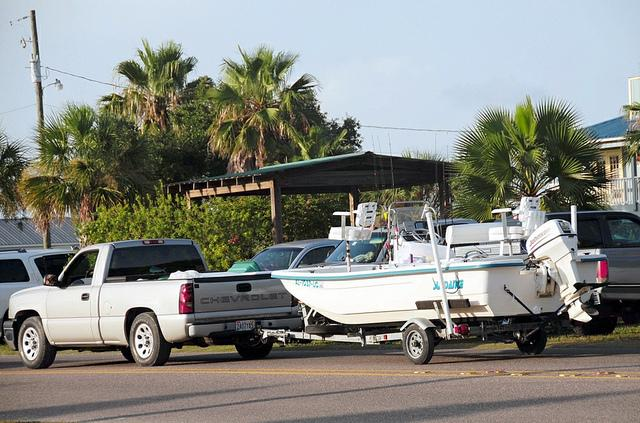What type of area is this?

Choices:
A) tropical
B) urban
C) mountains
D) farm tropical 